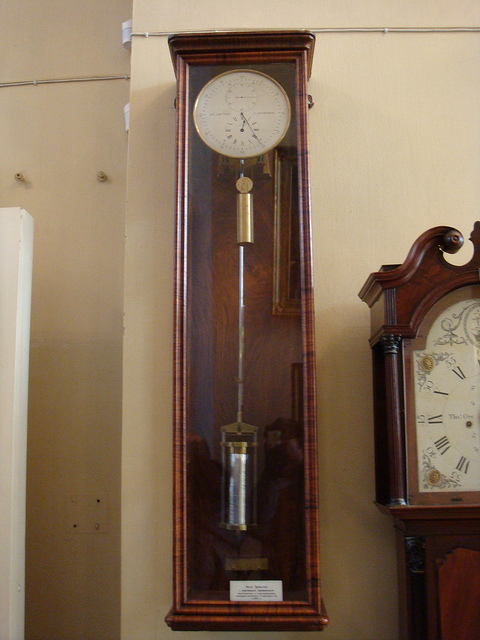<image>Which clock is digital? There is no digital clock pictured. Is this an Aunt clock? I don't know if this is an Aunt clock. It can be 'yes' or 'no'. Which clock is digital? I am not sure which clock is digital. None of the clocks in the image appear to be digital. Is this an Aunt clock? I don't know if this is an Aunt clock. It can be both an aunt clock or not. 